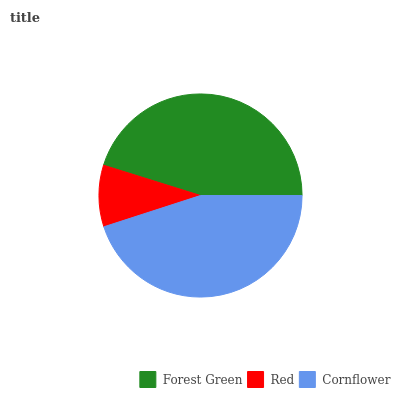Is Red the minimum?
Answer yes or no. Yes. Is Forest Green the maximum?
Answer yes or no. Yes. Is Cornflower the minimum?
Answer yes or no. No. Is Cornflower the maximum?
Answer yes or no. No. Is Cornflower greater than Red?
Answer yes or no. Yes. Is Red less than Cornflower?
Answer yes or no. Yes. Is Red greater than Cornflower?
Answer yes or no. No. Is Cornflower less than Red?
Answer yes or no. No. Is Cornflower the high median?
Answer yes or no. Yes. Is Cornflower the low median?
Answer yes or no. Yes. Is Red the high median?
Answer yes or no. No. Is Red the low median?
Answer yes or no. No. 